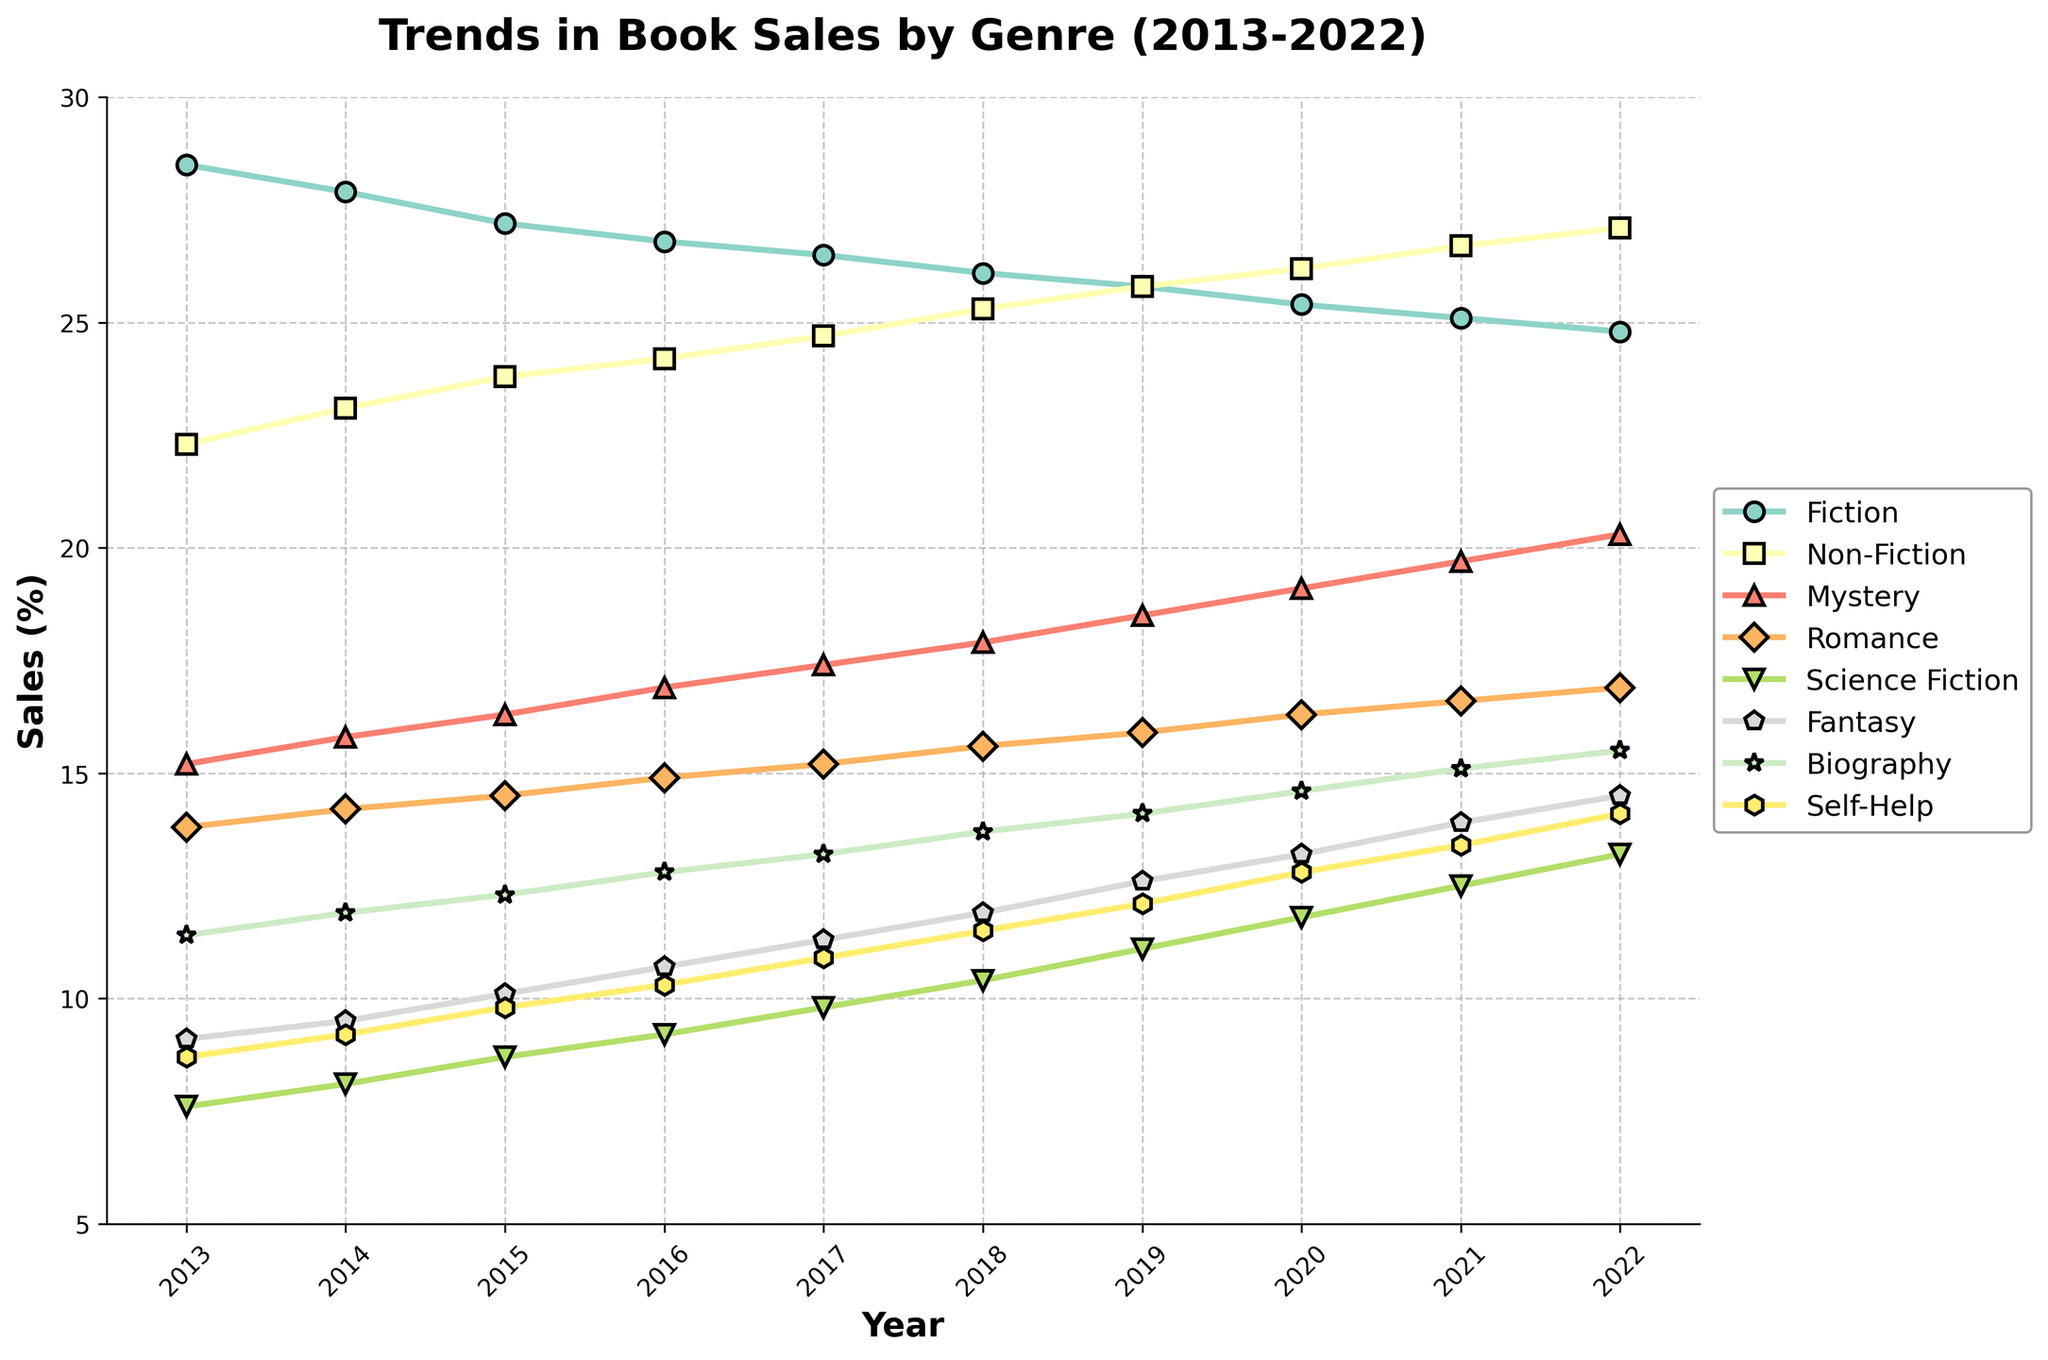what genre shows a steady increase in sales over the decade? Observe the line trends for each genre. Non-Fiction shows a steady increase from 22.3% in 2013 to 27.1% in 2022.
Answer: Non-Fiction how much did Science Fiction sales increase from 2013 to 2022? Look at the percentage for Science Fiction in 2013 (7.6%) and in 2022 (13.2%). Calculate the difference: 13.2% - 7.6% = 5.6%.
Answer: 5.6% which genre had the highest sales in 2022? Check the values for all genres in 2022. The highest value is 27.1% for Non-Fiction.
Answer: Non-Fiction in which year did Romance sales exceed Mystery sales, and by how much? Identify the years where Romance sales are higher than Mystery sales. In 2022, Romance is 16.9% and Mystery is 20.3%, so check previous recent years. In 2020, Romance (16.3%) exceeded Mystery (19.1%) by 2.8%.
Answer: 2020, by 2.8% what is the average sales percentage for Fantasy over the decade? Add the percentages for Fantasy from 2013 to 2022 and divide by the number of years (10): (9.1+9.5+10.1+10.7+11.3+11.9+12.6+13.2+13.9+14.5)/10 = 11.68%.
Answer: 11.68% which genre showed the most significant growth between 2013 and 2022? Calculate the differences between the sales percentages from 2013 to 2022 for each genre. The most significant growth is 27.1% - 22.3% = 4.8% for Non-Fiction.
Answer: Non-Fiction did any genre sales decline over the decade? Compare the percentages for each genre from 2013 to 2022. Fiction declined from 28.5% to 24.8%, a reduction of 3.7%.
Answer: Fiction during which years did Science Fiction sales increase the most sharply? Identify years where Science Fiction sales jump significantly. The most considerable increase is between 2019 (11.1%) and 2020 (11.8%), a rise of 0.7%.
Answer: 2019-2020 which genre had the least sales variance over the decade? Calculate the range (max-min) for each genre. Self-Help has the smallest range: 14.1% - 8.7% = 5.4%.
Answer: Self-Help which two genres had the closest sales percentages in 2022? Compare sales percentages for all genres in 2022. Biography (15.5%) and Romance (16.9%) are the closest with a difference of 1.4%.
Answer: Biography and Romance 